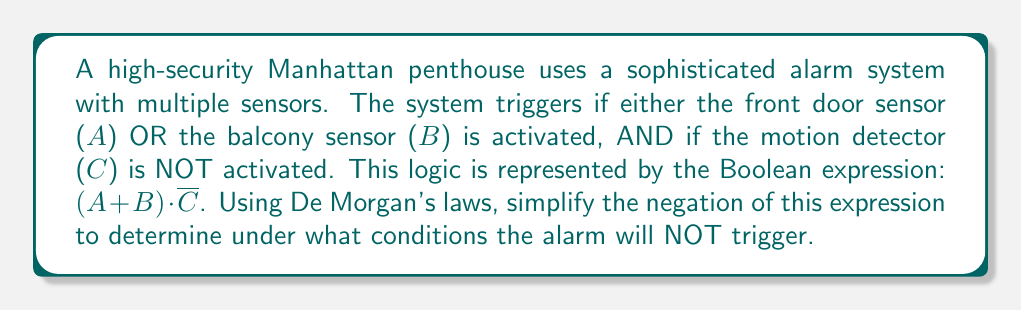Teach me how to tackle this problem. Let's approach this step-by-step:

1) The original expression for when the alarm triggers is:
   $$(A + B) \cdot \overline{C}$$

2) We want to find when the alarm does NOT trigger, so we negate the entire expression:
   $$\overline{(A + B) \cdot \overline{C}}$$

3) Applying De Morgan's first law to the outer negation:
   $$\overline{(A + B)} + C$$

4) Now, applying De Morgan's second law to $\overline{(A + B)}$:
   $$(\overline{A} \cdot \overline{B}) + C$$

5) This simplified expression represents when the alarm will NOT trigger.

6) Interpreting the result:
   - $\overline{A}$ means the front door sensor is NOT activated
   - $\overline{B}$ means the balcony sensor is NOT activated
   - $C$ means the motion detector IS activated

Therefore, the alarm will not trigger if EITHER:
- Both the front door and balcony sensors are inactive, OR
- The motion detector is active (regardless of the other sensors)
Answer: $(\overline{A} \cdot \overline{B}) + C$ 